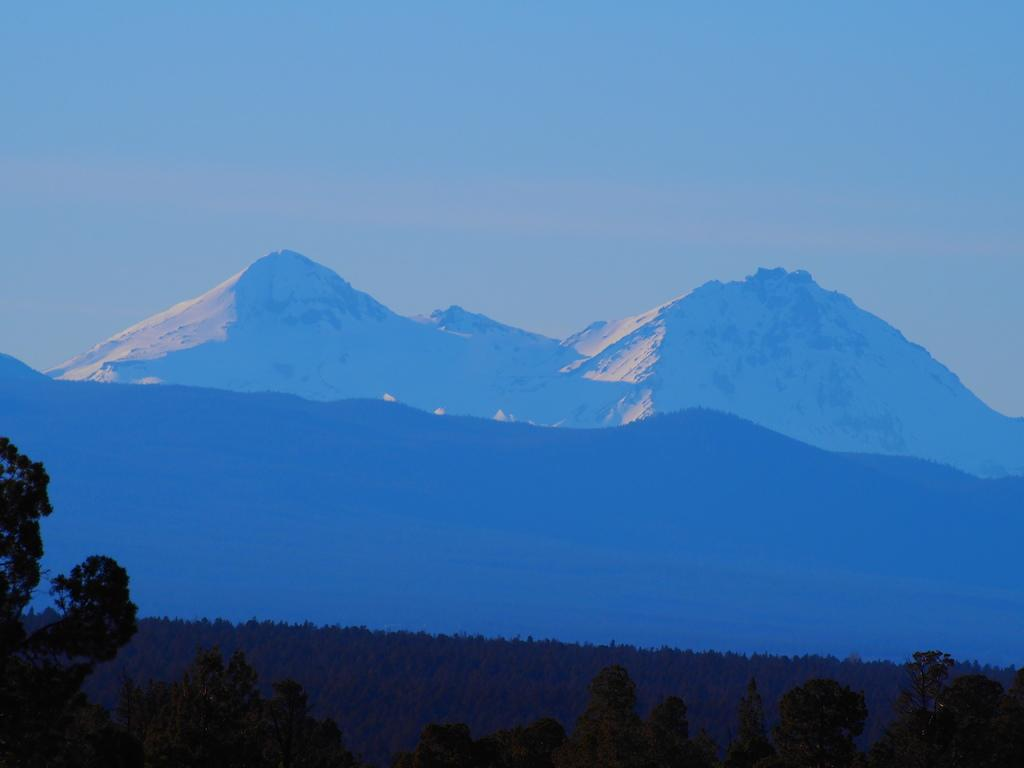What type of vegetation can be seen in the image? There are trees in front of the image. What natural features are visible in the background of the image? There are mountains and the sky visible in the background of the image. Can you see any crayons on the trees in the image? There are no crayons present in the image; it features trees, mountains, and the sky. Are there any cobwebs visible in the image? There is no mention of cobwebs in the provided facts, and therefore we cannot determine if any are present in the image. 